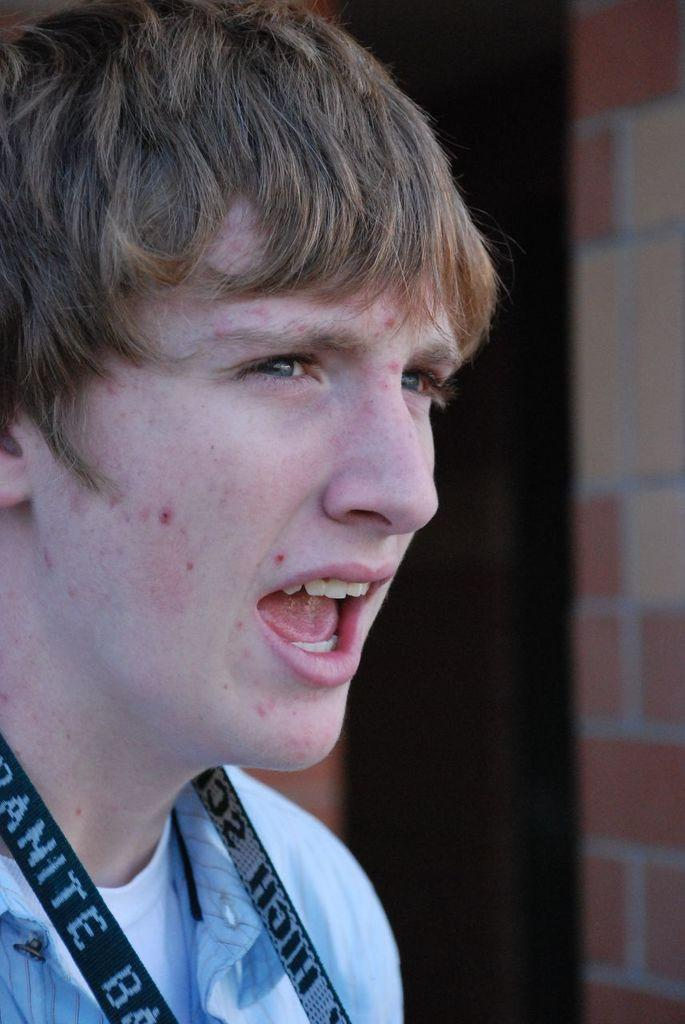Who is the main subject in the picture? There is a boy in the picture. What is the boy wearing? The boy is wearing a blue shirt. Can you describe any additional details about the boy? The boy has a tag around his neck. What is the boy doing in the picture? The boy is opening his mouth. What can be seen in the background of the picture? There is a wall with tiles in the picture. What type of fan is visible in the picture? There is no fan present in the picture; it features a boy with a tag around his neck, wearing a blue shirt, and opening his mouth in front of a wall with tiles. 